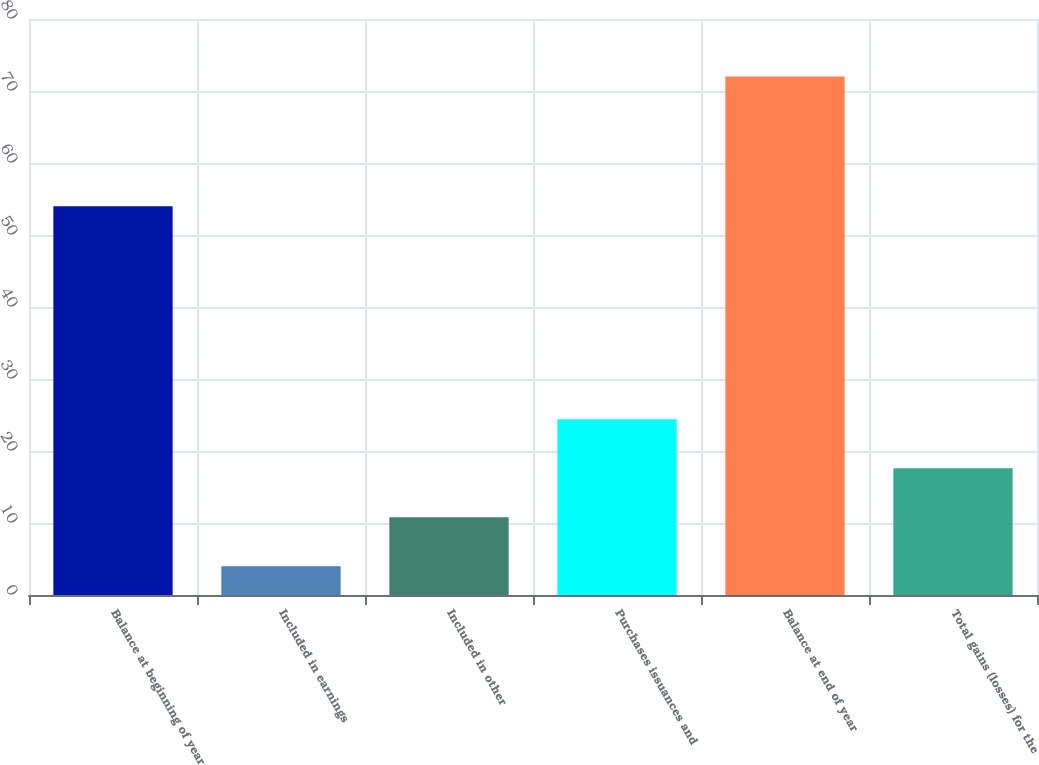Convert chart. <chart><loc_0><loc_0><loc_500><loc_500><bar_chart><fcel>Balance at beginning of year<fcel>Included in earnings<fcel>Included in other<fcel>Purchases issuances and<fcel>Balance at end of year<fcel>Total gains (losses) for the<nl><fcel>54<fcel>4<fcel>10.8<fcel>24.4<fcel>72<fcel>17.6<nl></chart> 